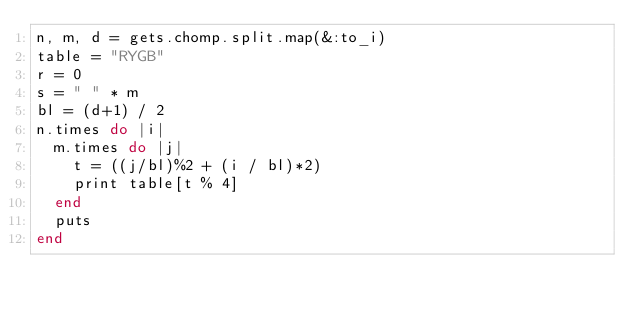<code> <loc_0><loc_0><loc_500><loc_500><_Ruby_>n, m, d = gets.chomp.split.map(&:to_i)
table = "RYGB"
r = 0
s = " " * m
bl = (d+1) / 2
n.times do |i|
  m.times do |j|
    t = ((j/bl)%2 + (i / bl)*2)
    print table[t % 4]
  end
  puts 
end </code> 